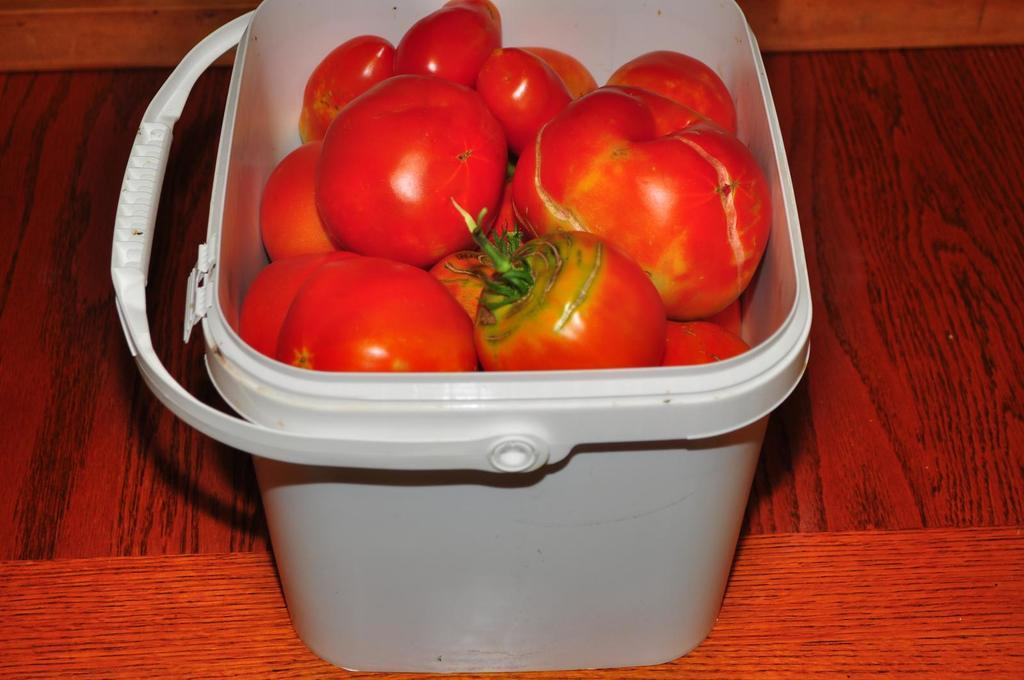What type of fruit is present in the image? There are tomatoes in the image. What color are the tomatoes? The tomatoes are red in color. How are the tomatoes arranged in the image? The tomatoes are in a basket. What is the color of the surface beneath the basket? The surface beneath the basket is brown and red in color. What health benefits do the girls in the image gain from eating the tomatoes? There are no girls present in the image, and therefore no one is eating the tomatoes. Additionally, the health benefits of tomatoes cannot be determined from the image alone. 